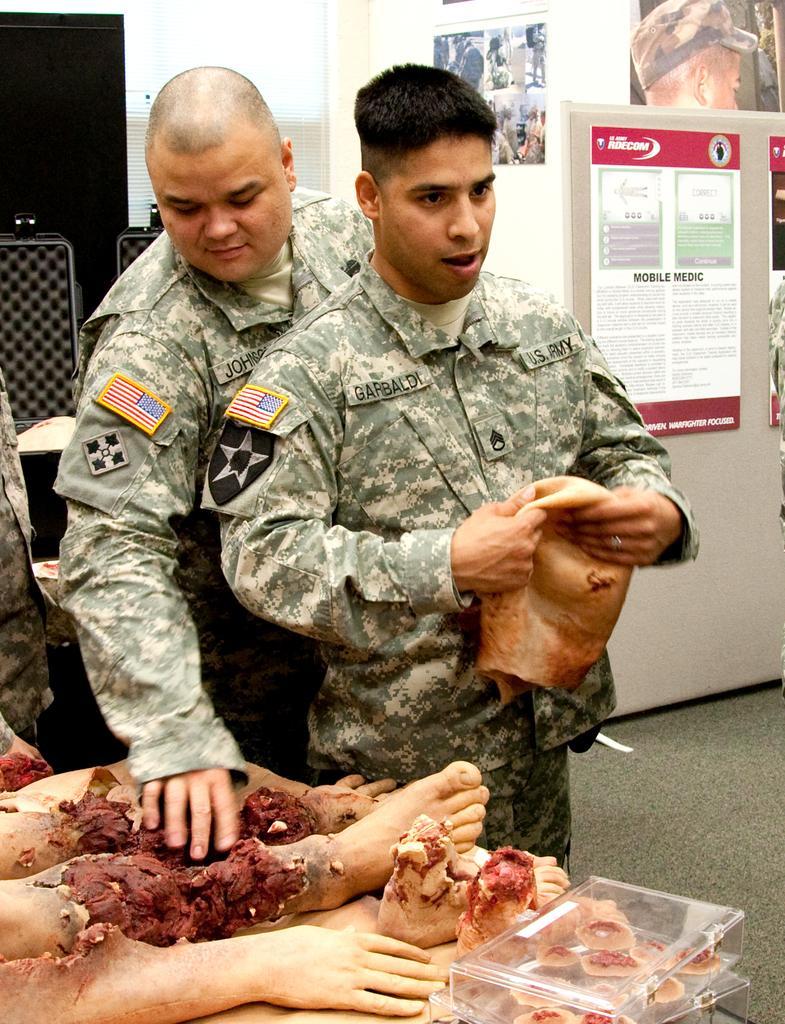In one or two sentences, can you explain what this image depicts? In the center of the image we can see men standing on the floor. At the left side of the image we can see human legs and hands. On the right side of the image there is a poster and a wall. 